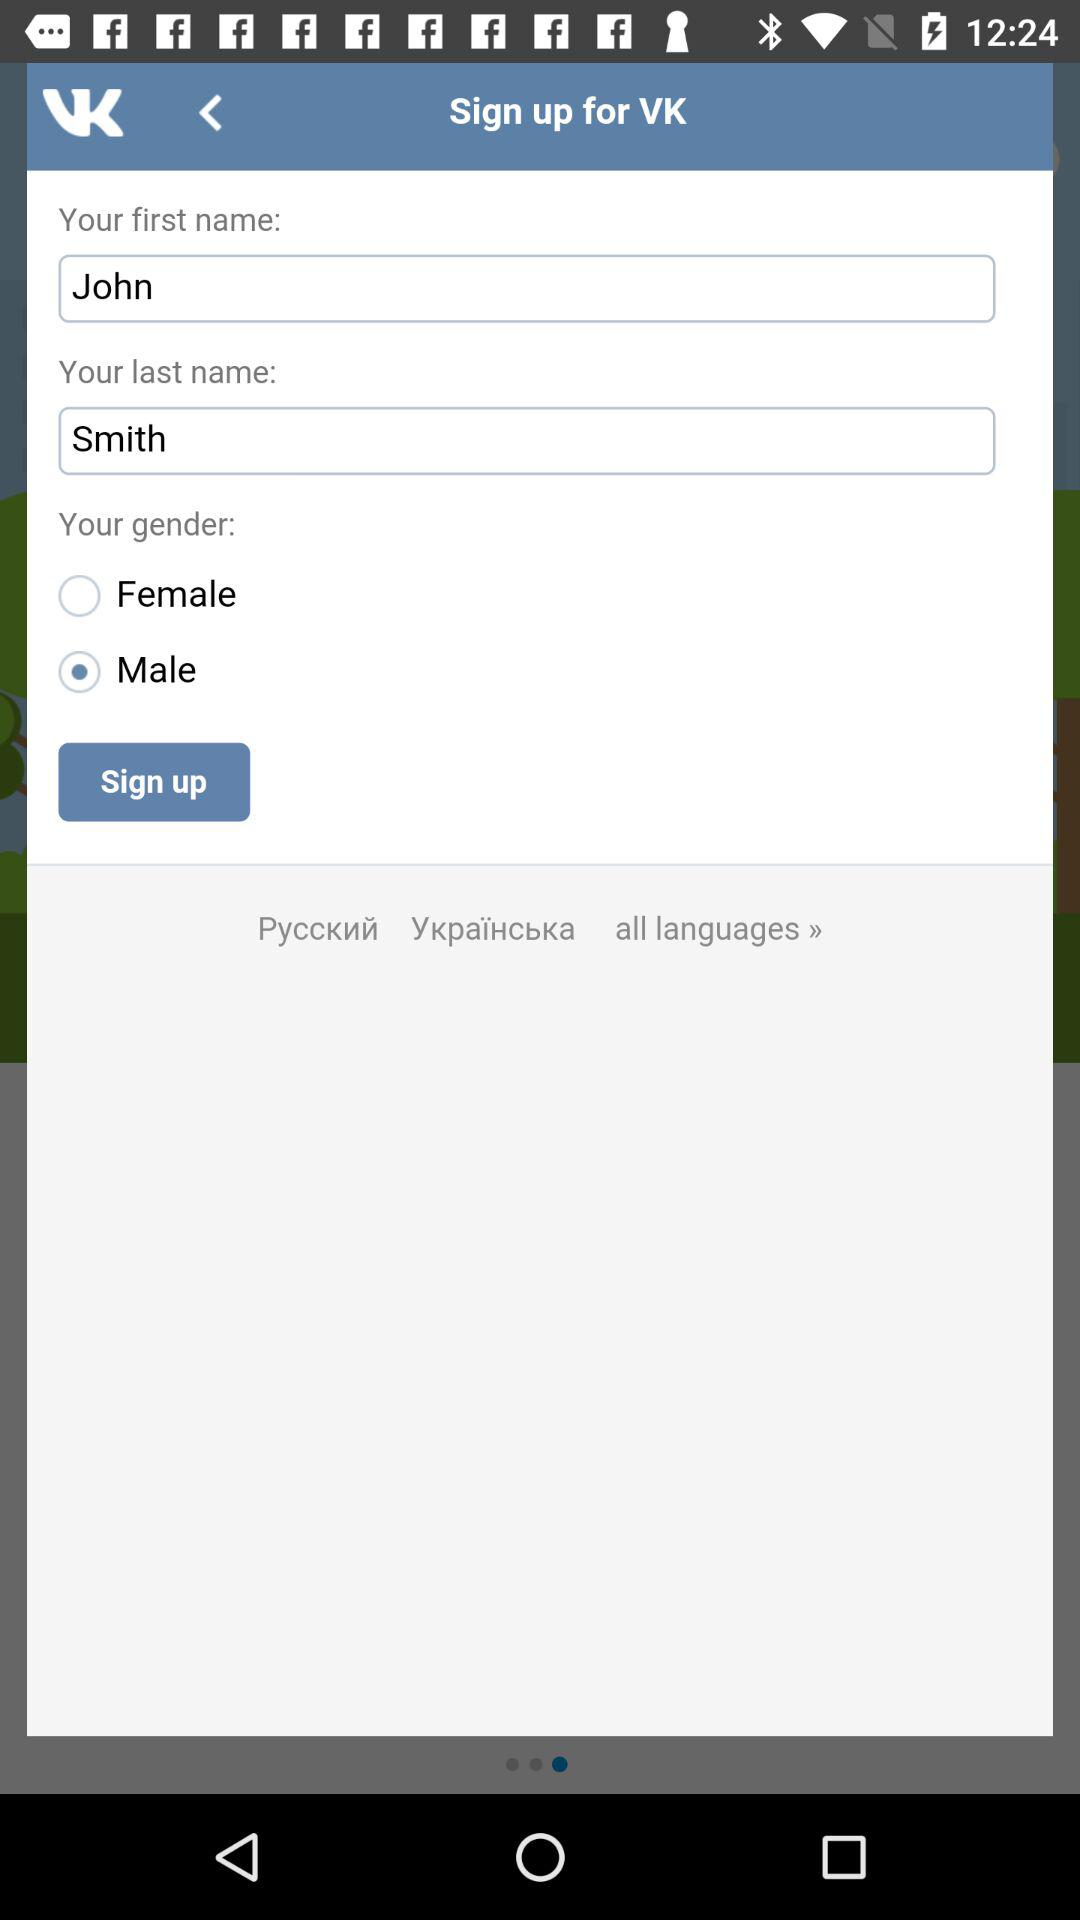What is the user's first name? The user's first name is John. 